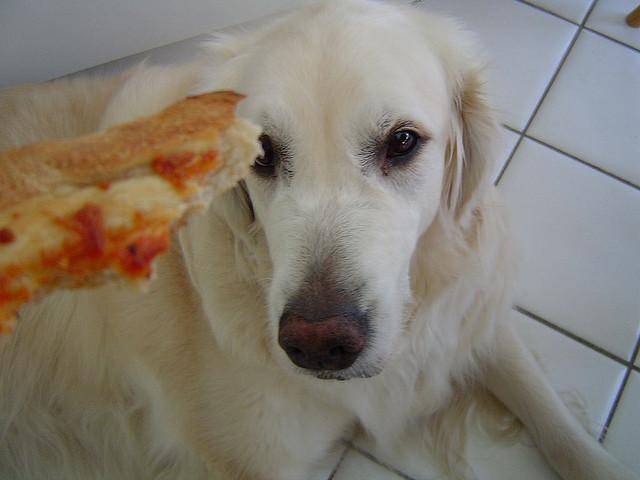Are the dog's eyes the same color?
Write a very short answer. Yes. What is the animal about to eat?
Write a very short answer. Pizza. Is the dog looking out a window?
Write a very short answer. No. What color is the dog?
Answer briefly. White. 